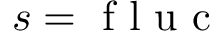<formula> <loc_0><loc_0><loc_500><loc_500>s = f l u c</formula> 